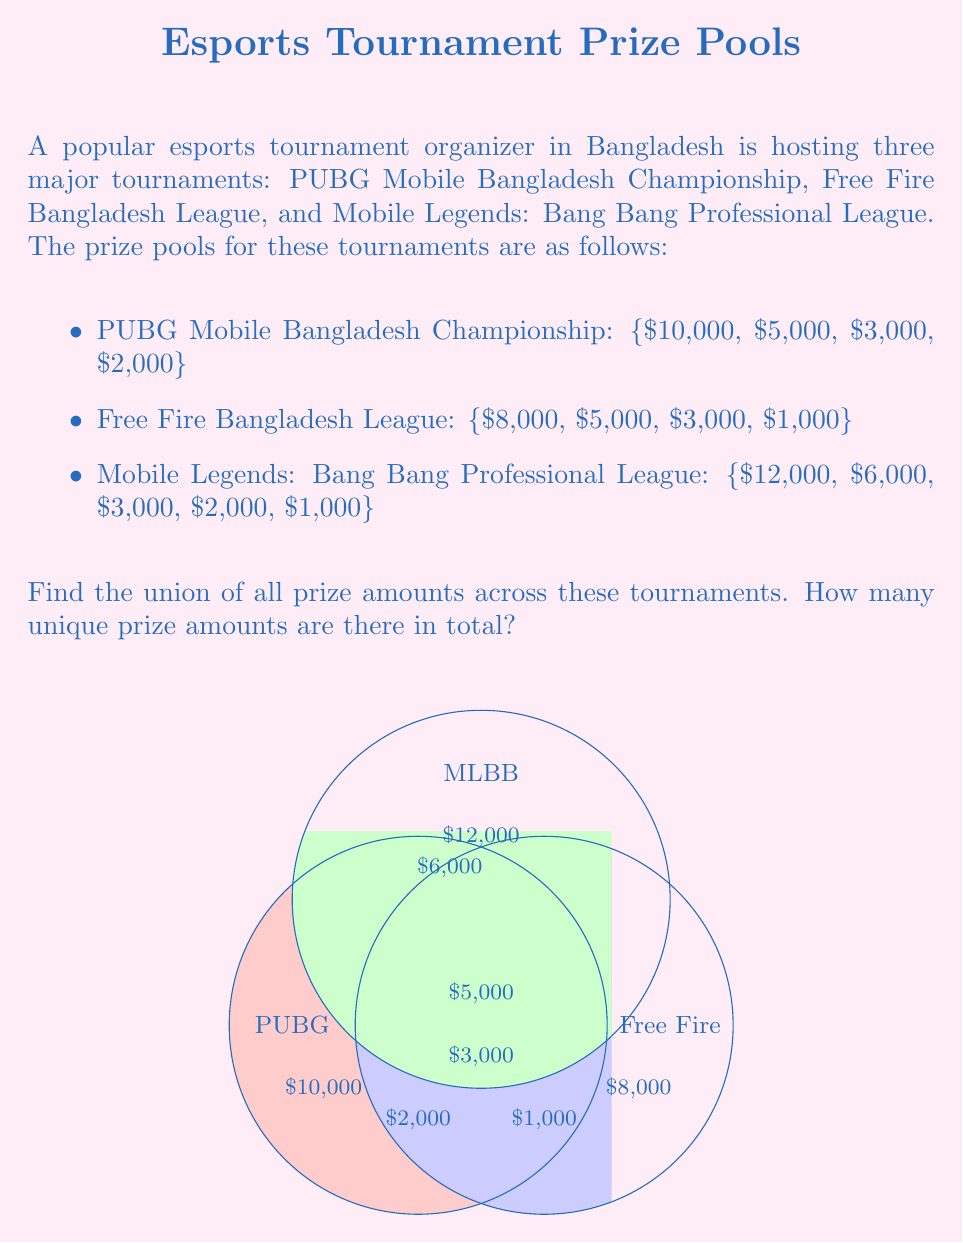Give your solution to this math problem. To find the union of prize amounts across all tournaments, we need to combine all unique values from each tournament's prize pool. Let's approach this step-by-step:

1) First, let's list out all the prize amounts from each tournament:

   PUBG Mobile: {$10,000, $5,000, $3,000, $2,000}
   Free Fire: {$8,000, $5,000, $3,000, $1,000}
   MLBB: {$12,000, $6,000, $3,000, $2,000, $1,000}

2) Now, we'll create a set containing all these amounts:

   $$U = \{10000, 5000, 3000, 2000, 8000, 1000, 12000, 6000\}$$

3) Notice that some amounts appear in multiple tournaments:
   - $5,000 appears in PUBG and Free Fire
   - $3,000 appears in all three tournaments
   - $2,000 appears in PUBG and MLBB
   - $1,000 appears in Free Fire and MLBB

   However, in a set, each element is only included once, regardless of how many times it appears in the original data.

4) Counting the unique elements in our union set:

   $$|U| = 8$$

Therefore, there are 8 unique prize amounts across all tournaments.
Answer: 8 